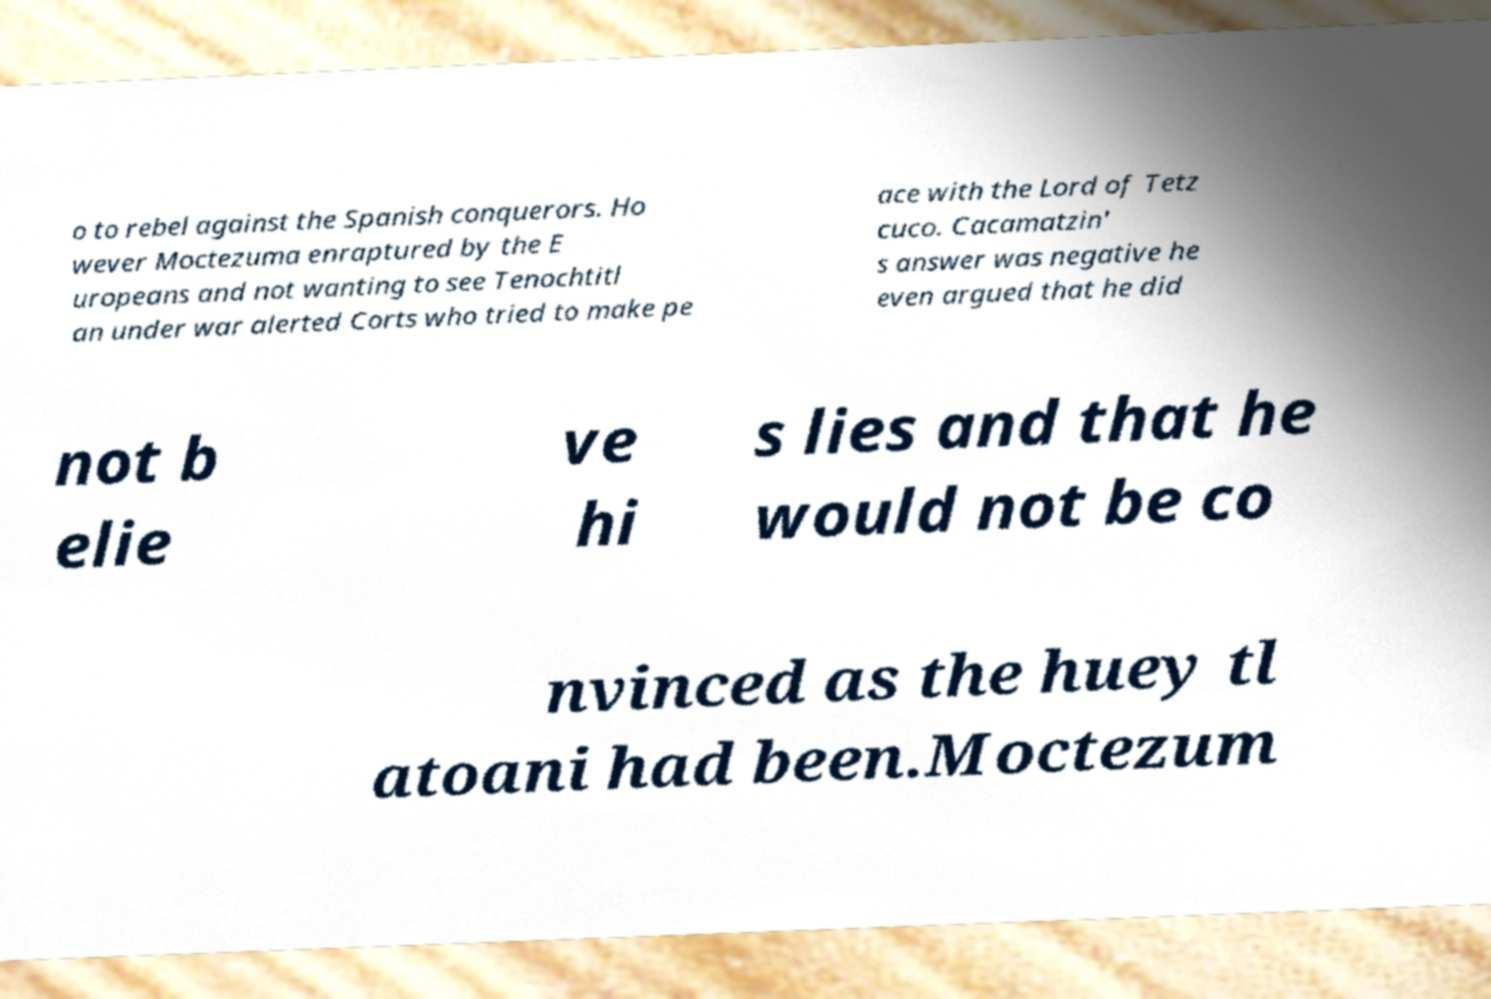There's text embedded in this image that I need extracted. Can you transcribe it verbatim? o to rebel against the Spanish conquerors. Ho wever Moctezuma enraptured by the E uropeans and not wanting to see Tenochtitl an under war alerted Corts who tried to make pe ace with the Lord of Tetz cuco. Cacamatzin' s answer was negative he even argued that he did not b elie ve hi s lies and that he would not be co nvinced as the huey tl atoani had been.Moctezum 